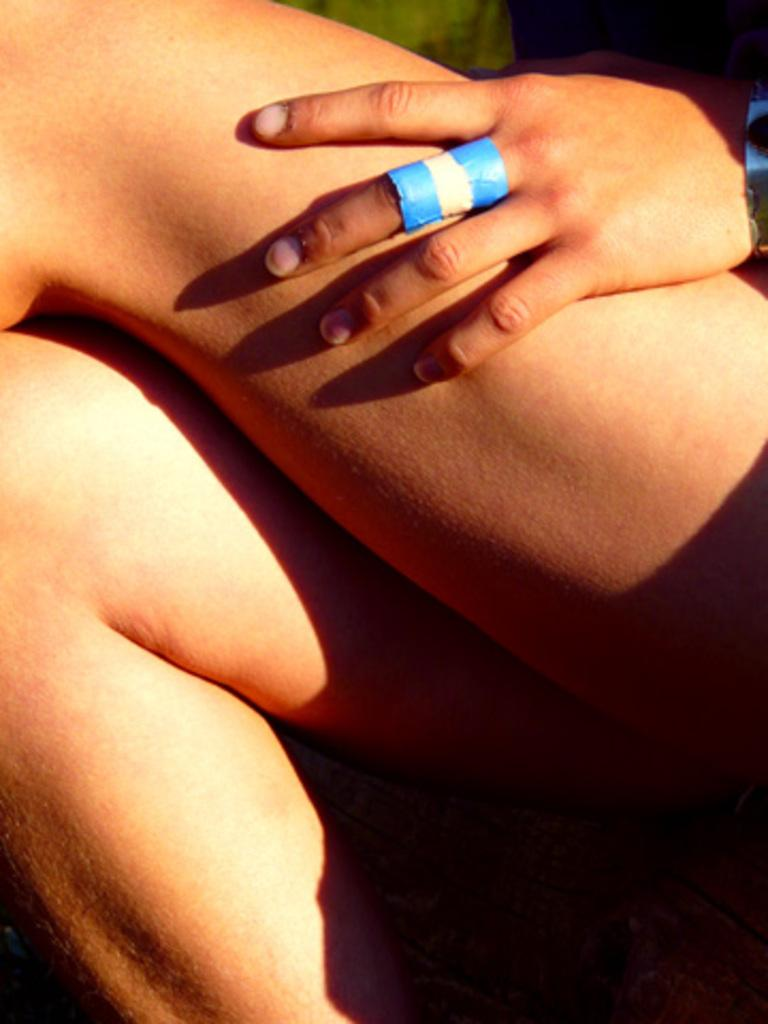Who or what is the main subject in the image? There is a person in the image. What part of the person's body can be seen in the image? The person's legs and hand are visible in the image. What is the person holding in their hand? There is a blue color paper in the person's hand. What are the person's hobbies, as indicated by the image? The image does not provide any information about the person's hobbies. 